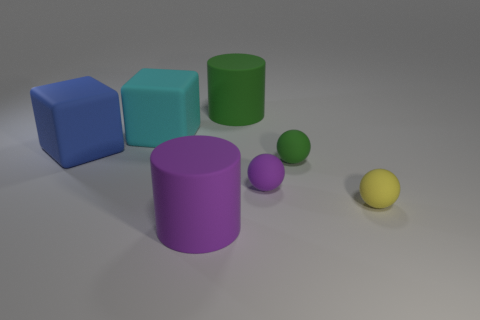Subtract 1 blocks. How many blocks are left? 1 Add 2 tiny yellow matte objects. How many objects exist? 9 Subtract all purple spheres. How many spheres are left? 2 Subtract all balls. How many objects are left? 4 Subtract all brown cylinders. Subtract all blue spheres. How many cylinders are left? 2 Subtract all cyan spheres. How many cyan cubes are left? 1 Subtract all spheres. Subtract all purple rubber cylinders. How many objects are left? 3 Add 1 large rubber cubes. How many large rubber cubes are left? 3 Add 2 small red rubber cylinders. How many small red rubber cylinders exist? 2 Subtract 0 purple blocks. How many objects are left? 7 